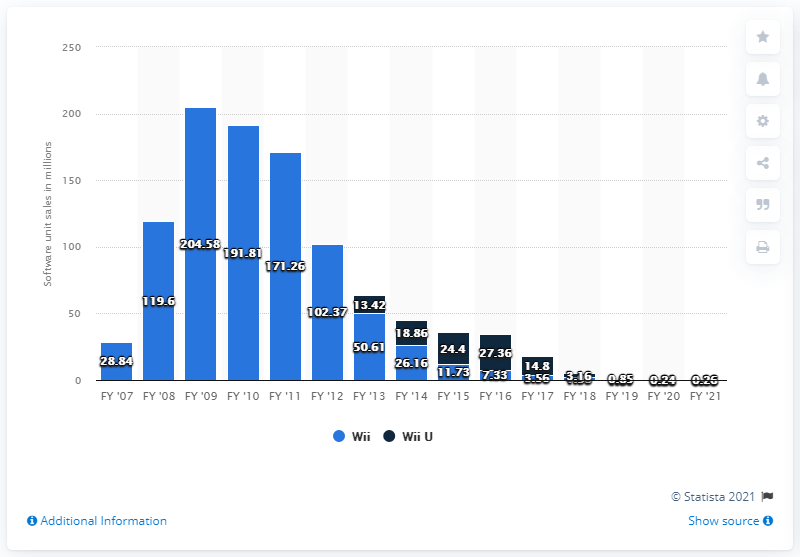Give some essential details in this illustration. In 2012, 0.16 units of Wii software were sold. 